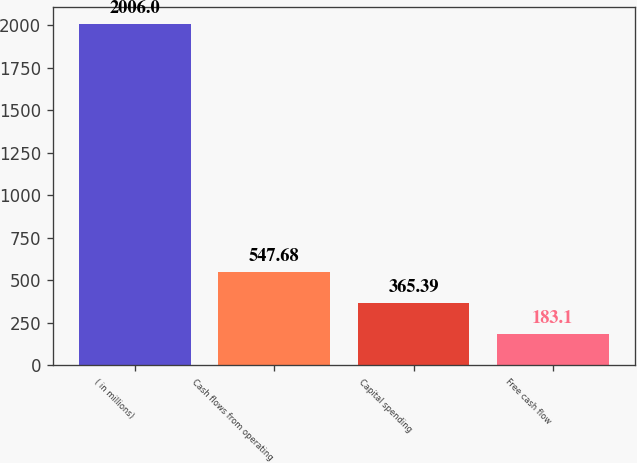Convert chart to OTSL. <chart><loc_0><loc_0><loc_500><loc_500><bar_chart><fcel>( in millions)<fcel>Cash flows from operating<fcel>Capital spending<fcel>Free cash flow<nl><fcel>2006<fcel>547.68<fcel>365.39<fcel>183.1<nl></chart> 